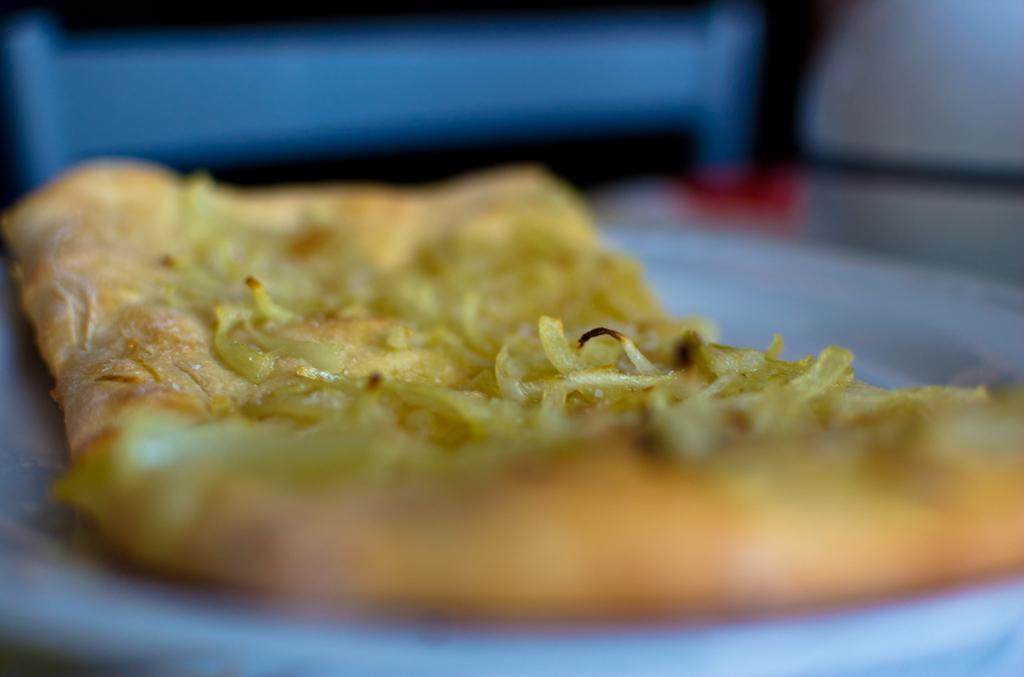What is on the plate in the image? There is a food item on a plate in the image. What action is the flame performing on the food item in the image? There is no flame present in the image, so it cannot perform any action on the food item. 